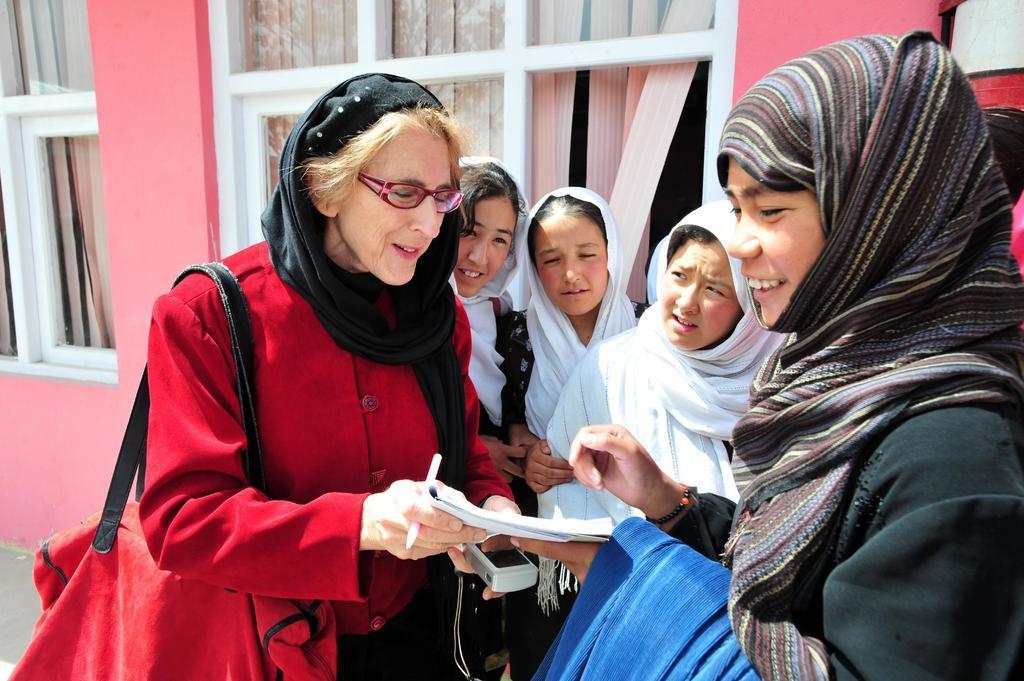How would you summarize this image in a sentence or two? In this picture I can see an old man is holding the book and talking, she wore red color coat and a hand bag. On the right side there is a woman laughing, she wore black color dress. In the middle three women are there, they wore white color clothes. Behind them there are glass windows with curtains. 